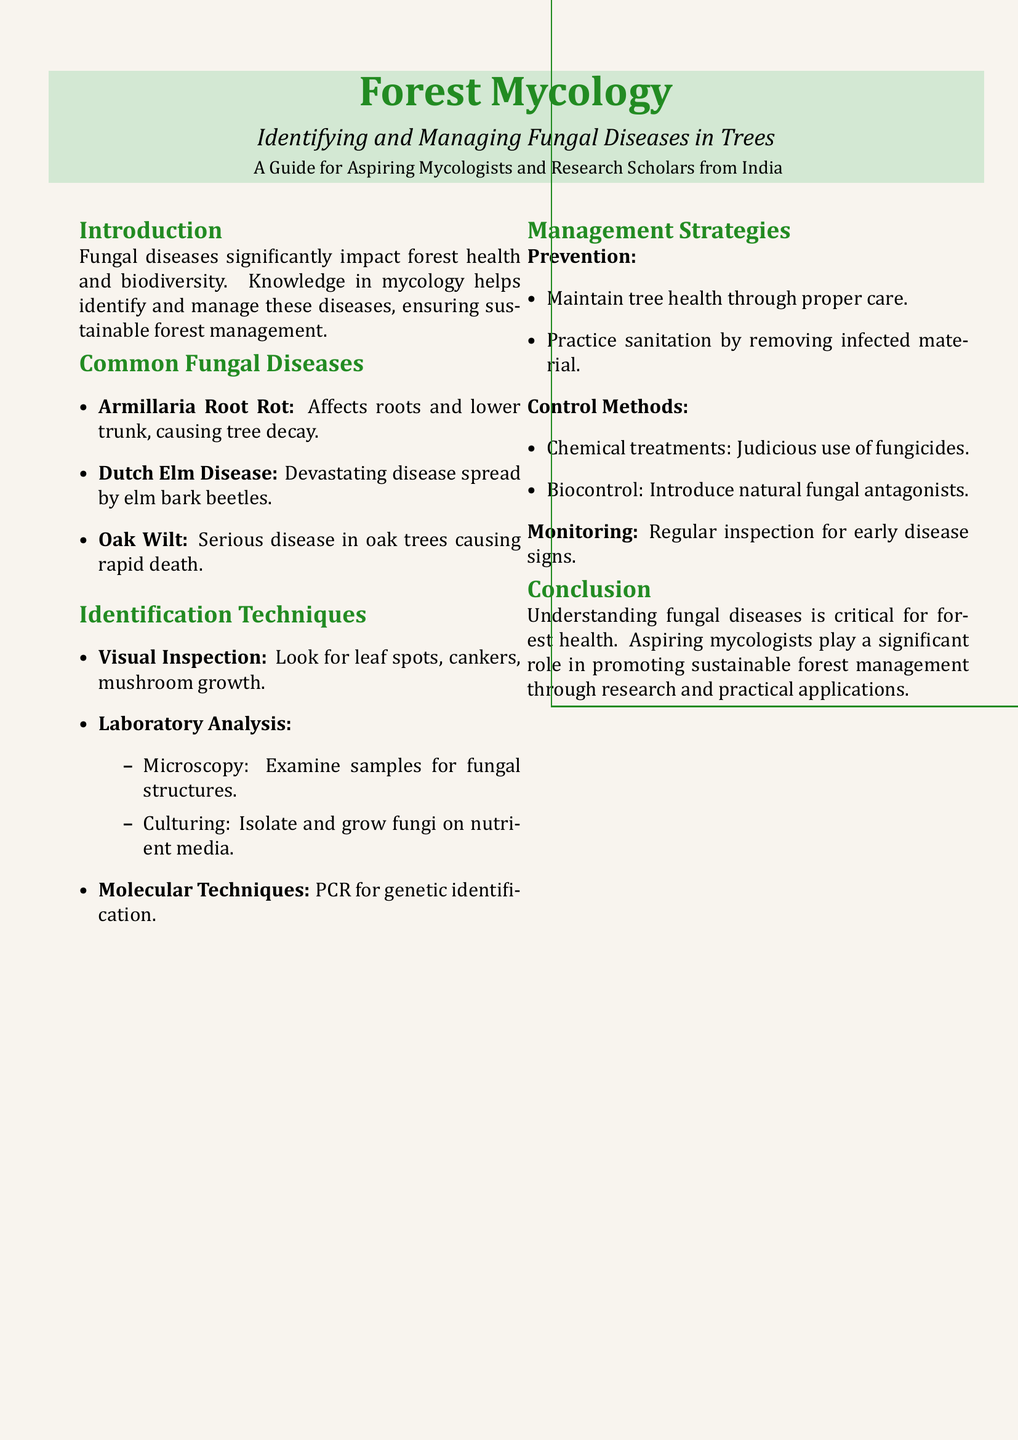What are the common fungal diseases mentioned? The document lists specific diseases affecting trees, specifically those that impact forest health.
Answer: Armillaria Root Rot, Dutch Elm Disease, Oak Wilt What is one identification technique for fungal diseases? The document provides multiple techniques for identifying fungal diseases, focusing on visual and laboratory methods.
Answer: Visual Inspection What does PCR stand for in the context of identification techniques? PCR is mentioned as a molecular technique for genetic identification; it is also a common abbreviation in scientific contexts.
Answer: Polymerase Chain Reaction What is one prevention method for managing fungal diseases? The document outlines strategies for managing fungal diseases, highlighting methods to reduce infection risk.
Answer: Maintain tree health Which disease spreads through elm bark beetles? The document names specific diseases associated with tree health and their vectors or causes.
Answer: Dutch Elm Disease What type of treatments may be used to control fungal diseases? The management section of the document discusses different methods, emphasizing the importance of controlling fungal spread.
Answer: Chemical treatments What is essential for sustainable forest management according to the document? The document emphasizes the role of mycologists in maintaining forest health through specific practices and knowledge.
Answer: Understanding fungal diseases What is one method of laboratory analysis mentioned? The document includes different analytical methods for identifying fungi, focusing on laboratory-based techniques.
Answer: Microscopy What color is used for the background of the document? The document describes the color scheme used for the flyer, which enhances its visual appeal.
Answer: Light brown 